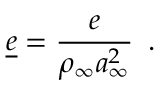<formula> <loc_0><loc_0><loc_500><loc_500>\underline { e } = \frac { e } { \rho _ { \infty } a _ { \infty } ^ { 2 } } \, .</formula> 